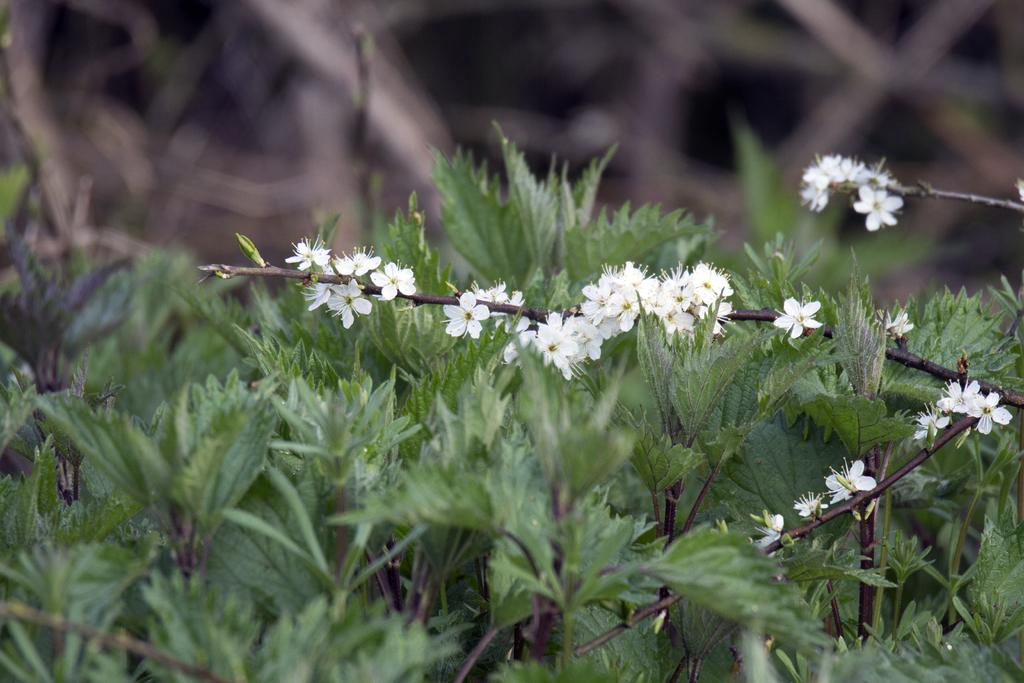What is the main subject of the image? The main subject of the image is plants. Can you describe the plants in the image? The plants in the image have flowers. What can be observed about the background of the image? The background of the image is blurry. How many mice can be seen playing with the flowers in the image? There are no mice present in the image; it features plants with flowers. What attraction is visible in the background of the image? There is no attraction visible in the image; the background is blurry. 